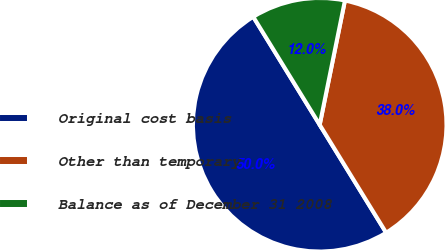<chart> <loc_0><loc_0><loc_500><loc_500><pie_chart><fcel>Original cost basis<fcel>Other than temporary<fcel>Balance as of December 31 2008<nl><fcel>50.0%<fcel>38.03%<fcel>11.97%<nl></chart> 